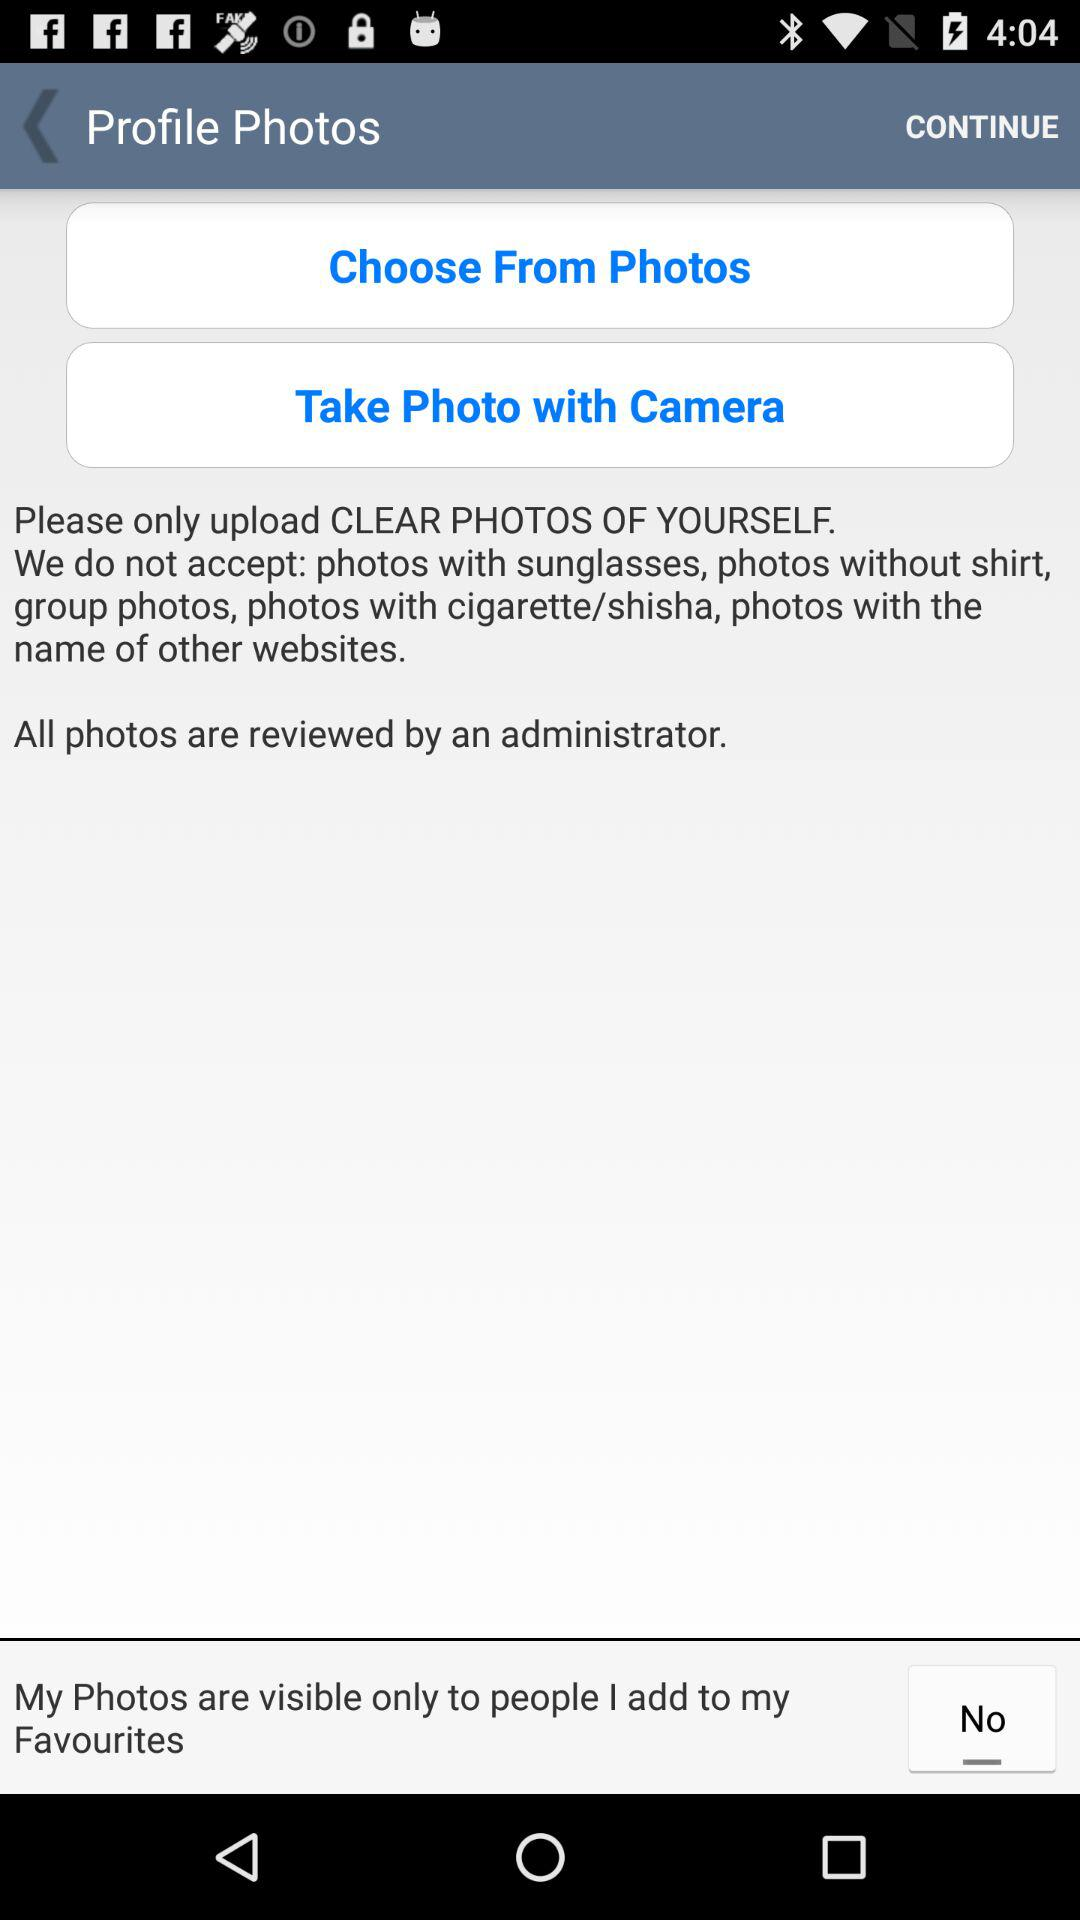What type of photo can we only upload? You can only upload clear photos of yourself. 